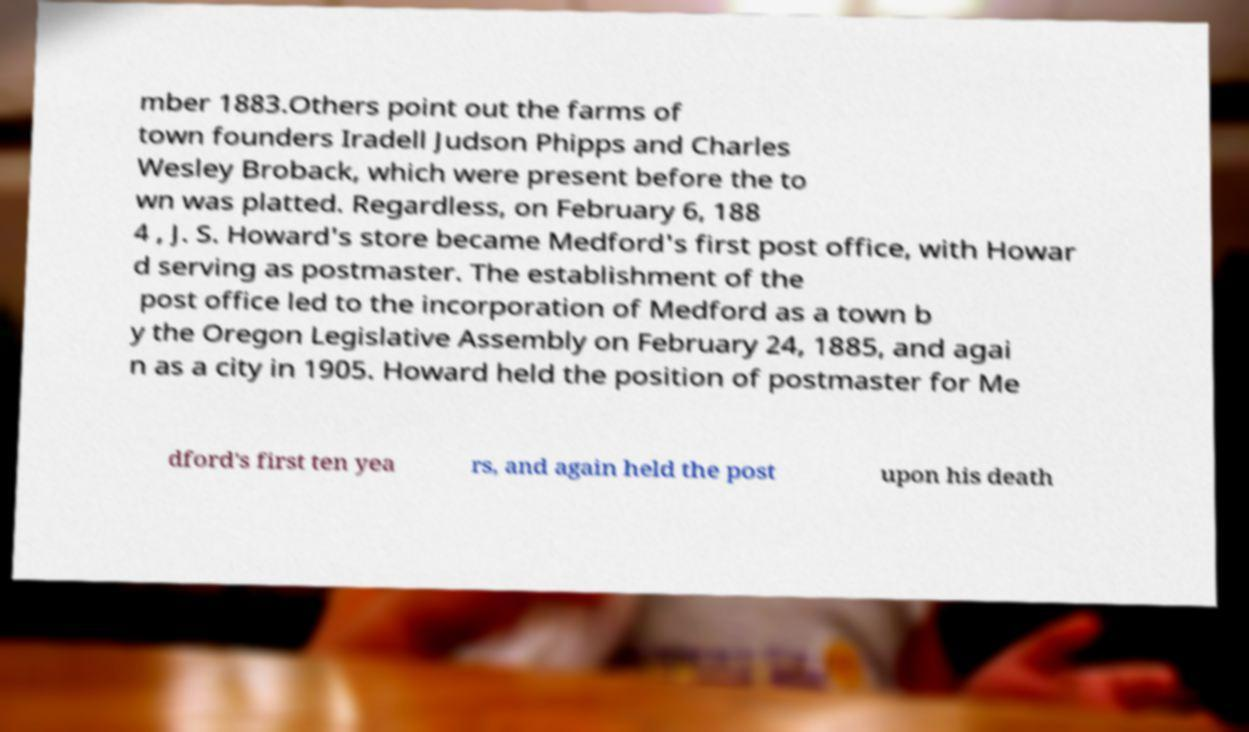I need the written content from this picture converted into text. Can you do that? mber 1883.Others point out the farms of town founders Iradell Judson Phipps and Charles Wesley Broback, which were present before the to wn was platted. Regardless, on February 6, 188 4 , J. S. Howard's store became Medford's first post office, with Howar d serving as postmaster. The establishment of the post office led to the incorporation of Medford as a town b y the Oregon Legislative Assembly on February 24, 1885, and agai n as a city in 1905. Howard held the position of postmaster for Me dford's first ten yea rs, and again held the post upon his death 